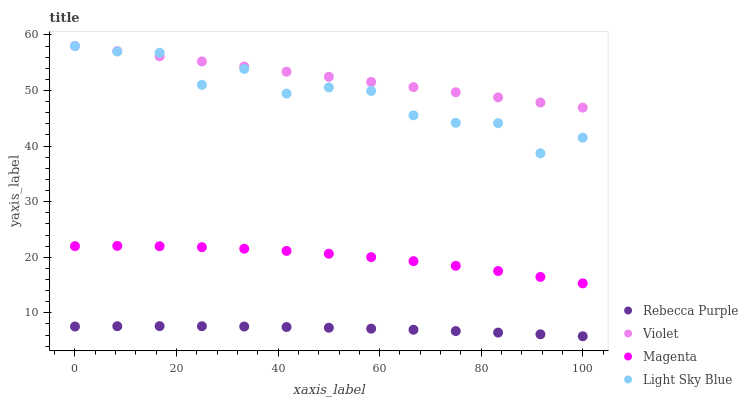Does Rebecca Purple have the minimum area under the curve?
Answer yes or no. Yes. Does Violet have the maximum area under the curve?
Answer yes or no. Yes. Does Light Sky Blue have the minimum area under the curve?
Answer yes or no. No. Does Light Sky Blue have the maximum area under the curve?
Answer yes or no. No. Is Violet the smoothest?
Answer yes or no. Yes. Is Light Sky Blue the roughest?
Answer yes or no. Yes. Is Rebecca Purple the smoothest?
Answer yes or no. No. Is Rebecca Purple the roughest?
Answer yes or no. No. Does Rebecca Purple have the lowest value?
Answer yes or no. Yes. Does Light Sky Blue have the lowest value?
Answer yes or no. No. Does Violet have the highest value?
Answer yes or no. Yes. Does Rebecca Purple have the highest value?
Answer yes or no. No. Is Rebecca Purple less than Violet?
Answer yes or no. Yes. Is Magenta greater than Rebecca Purple?
Answer yes or no. Yes. Does Violet intersect Light Sky Blue?
Answer yes or no. Yes. Is Violet less than Light Sky Blue?
Answer yes or no. No. Is Violet greater than Light Sky Blue?
Answer yes or no. No. Does Rebecca Purple intersect Violet?
Answer yes or no. No. 